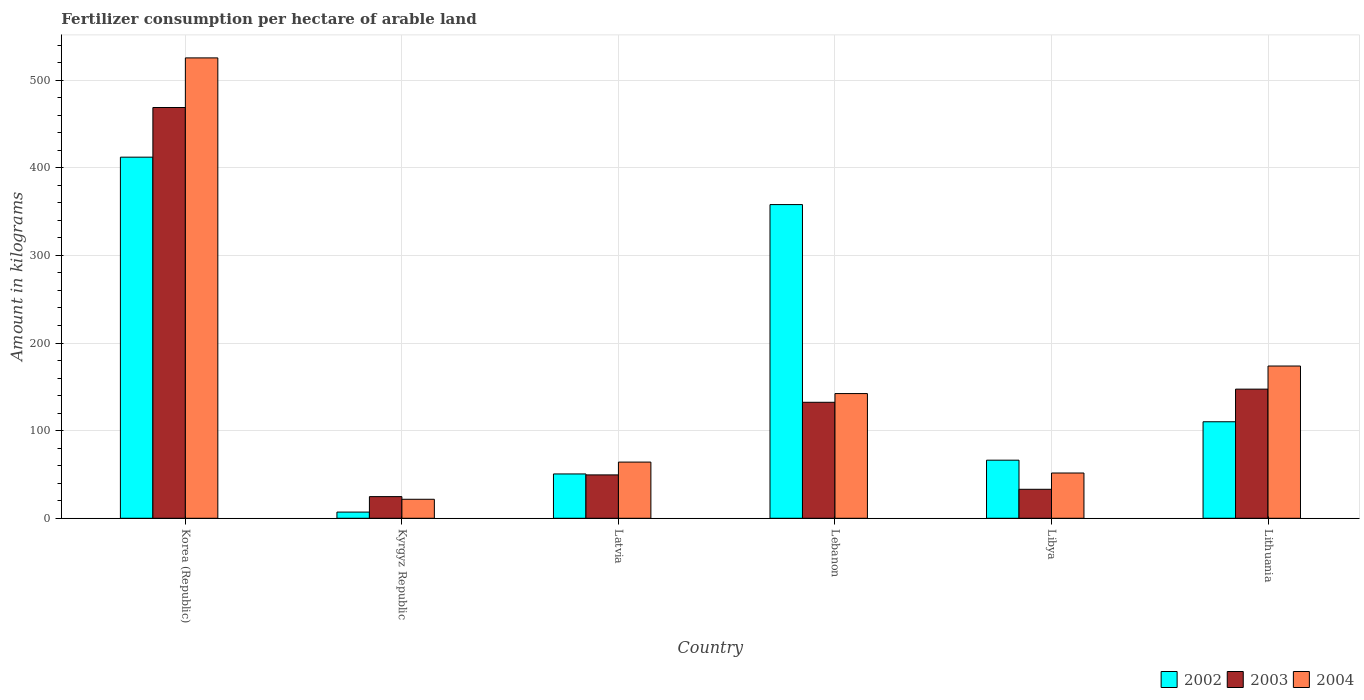How many different coloured bars are there?
Provide a short and direct response. 3. How many groups of bars are there?
Keep it short and to the point. 6. Are the number of bars per tick equal to the number of legend labels?
Provide a short and direct response. Yes. Are the number of bars on each tick of the X-axis equal?
Make the answer very short. Yes. How many bars are there on the 1st tick from the left?
Make the answer very short. 3. How many bars are there on the 3rd tick from the right?
Keep it short and to the point. 3. What is the label of the 3rd group of bars from the left?
Provide a succinct answer. Latvia. What is the amount of fertilizer consumption in 2004 in Libya?
Provide a succinct answer. 51.66. Across all countries, what is the maximum amount of fertilizer consumption in 2004?
Provide a succinct answer. 525.42. Across all countries, what is the minimum amount of fertilizer consumption in 2004?
Offer a terse response. 21.68. In which country was the amount of fertilizer consumption in 2004 maximum?
Ensure brevity in your answer.  Korea (Republic). In which country was the amount of fertilizer consumption in 2004 minimum?
Make the answer very short. Kyrgyz Republic. What is the total amount of fertilizer consumption in 2003 in the graph?
Your answer should be compact. 855.82. What is the difference between the amount of fertilizer consumption in 2004 in Korea (Republic) and that in Libya?
Provide a succinct answer. 473.77. What is the difference between the amount of fertilizer consumption in 2003 in Libya and the amount of fertilizer consumption in 2004 in Latvia?
Your answer should be compact. -31.06. What is the average amount of fertilizer consumption in 2004 per country?
Offer a very short reply. 163.16. What is the difference between the amount of fertilizer consumption of/in 2002 and amount of fertilizer consumption of/in 2003 in Lebanon?
Provide a succinct answer. 225.62. What is the ratio of the amount of fertilizer consumption in 2004 in Kyrgyz Republic to that in Latvia?
Provide a short and direct response. 0.34. Is the amount of fertilizer consumption in 2002 in Latvia less than that in Libya?
Your answer should be compact. Yes. What is the difference between the highest and the second highest amount of fertilizer consumption in 2002?
Offer a very short reply. -301.97. What is the difference between the highest and the lowest amount of fertilizer consumption in 2003?
Keep it short and to the point. 444.08. Is the sum of the amount of fertilizer consumption in 2003 in Lebanon and Libya greater than the maximum amount of fertilizer consumption in 2004 across all countries?
Your answer should be very brief. No. Is it the case that in every country, the sum of the amount of fertilizer consumption in 2003 and amount of fertilizer consumption in 2002 is greater than the amount of fertilizer consumption in 2004?
Make the answer very short. Yes. How many bars are there?
Offer a terse response. 18. How many countries are there in the graph?
Your response must be concise. 6. What is the difference between two consecutive major ticks on the Y-axis?
Provide a short and direct response. 100. How many legend labels are there?
Ensure brevity in your answer.  3. What is the title of the graph?
Offer a terse response. Fertilizer consumption per hectare of arable land. What is the label or title of the X-axis?
Offer a terse response. Country. What is the label or title of the Y-axis?
Your response must be concise. Amount in kilograms. What is the Amount in kilograms of 2002 in Korea (Republic)?
Provide a succinct answer. 412.13. What is the Amount in kilograms of 2003 in Korea (Republic)?
Offer a terse response. 468.79. What is the Amount in kilograms in 2004 in Korea (Republic)?
Provide a succinct answer. 525.42. What is the Amount in kilograms of 2002 in Kyrgyz Republic?
Make the answer very short. 7.05. What is the Amount in kilograms of 2003 in Kyrgyz Republic?
Keep it short and to the point. 24.71. What is the Amount in kilograms of 2004 in Kyrgyz Republic?
Provide a succinct answer. 21.68. What is the Amount in kilograms of 2002 in Latvia?
Keep it short and to the point. 50.6. What is the Amount in kilograms of 2003 in Latvia?
Offer a terse response. 49.49. What is the Amount in kilograms in 2004 in Latvia?
Your answer should be compact. 64.13. What is the Amount in kilograms of 2002 in Lebanon?
Provide a short and direct response. 358. What is the Amount in kilograms of 2003 in Lebanon?
Your answer should be very brief. 132.38. What is the Amount in kilograms in 2004 in Lebanon?
Offer a terse response. 142.32. What is the Amount in kilograms of 2002 in Libya?
Your answer should be very brief. 66.29. What is the Amount in kilograms in 2003 in Libya?
Your answer should be very brief. 33.07. What is the Amount in kilograms in 2004 in Libya?
Provide a succinct answer. 51.66. What is the Amount in kilograms of 2002 in Lithuania?
Your answer should be compact. 110.15. What is the Amount in kilograms in 2003 in Lithuania?
Make the answer very short. 147.38. What is the Amount in kilograms of 2004 in Lithuania?
Keep it short and to the point. 173.76. Across all countries, what is the maximum Amount in kilograms in 2002?
Offer a terse response. 412.13. Across all countries, what is the maximum Amount in kilograms in 2003?
Offer a terse response. 468.79. Across all countries, what is the maximum Amount in kilograms in 2004?
Your answer should be very brief. 525.42. Across all countries, what is the minimum Amount in kilograms of 2002?
Offer a very short reply. 7.05. Across all countries, what is the minimum Amount in kilograms of 2003?
Give a very brief answer. 24.71. Across all countries, what is the minimum Amount in kilograms of 2004?
Offer a very short reply. 21.68. What is the total Amount in kilograms of 2002 in the graph?
Offer a very short reply. 1004.22. What is the total Amount in kilograms of 2003 in the graph?
Make the answer very short. 855.82. What is the total Amount in kilograms of 2004 in the graph?
Make the answer very short. 978.97. What is the difference between the Amount in kilograms of 2002 in Korea (Republic) and that in Kyrgyz Republic?
Provide a short and direct response. 405.08. What is the difference between the Amount in kilograms in 2003 in Korea (Republic) and that in Kyrgyz Republic?
Keep it short and to the point. 444.08. What is the difference between the Amount in kilograms of 2004 in Korea (Republic) and that in Kyrgyz Republic?
Ensure brevity in your answer.  503.74. What is the difference between the Amount in kilograms of 2002 in Korea (Republic) and that in Latvia?
Provide a short and direct response. 361.53. What is the difference between the Amount in kilograms in 2003 in Korea (Republic) and that in Latvia?
Your response must be concise. 419.3. What is the difference between the Amount in kilograms of 2004 in Korea (Republic) and that in Latvia?
Make the answer very short. 461.29. What is the difference between the Amount in kilograms of 2002 in Korea (Republic) and that in Lebanon?
Offer a terse response. 54.13. What is the difference between the Amount in kilograms of 2003 in Korea (Republic) and that in Lebanon?
Make the answer very short. 336.42. What is the difference between the Amount in kilograms of 2004 in Korea (Republic) and that in Lebanon?
Provide a succinct answer. 383.1. What is the difference between the Amount in kilograms of 2002 in Korea (Republic) and that in Libya?
Your response must be concise. 345.84. What is the difference between the Amount in kilograms of 2003 in Korea (Republic) and that in Libya?
Ensure brevity in your answer.  435.72. What is the difference between the Amount in kilograms in 2004 in Korea (Republic) and that in Libya?
Give a very brief answer. 473.77. What is the difference between the Amount in kilograms in 2002 in Korea (Republic) and that in Lithuania?
Make the answer very short. 301.97. What is the difference between the Amount in kilograms in 2003 in Korea (Republic) and that in Lithuania?
Ensure brevity in your answer.  321.41. What is the difference between the Amount in kilograms of 2004 in Korea (Republic) and that in Lithuania?
Give a very brief answer. 351.66. What is the difference between the Amount in kilograms in 2002 in Kyrgyz Republic and that in Latvia?
Your answer should be very brief. -43.54. What is the difference between the Amount in kilograms in 2003 in Kyrgyz Republic and that in Latvia?
Ensure brevity in your answer.  -24.78. What is the difference between the Amount in kilograms of 2004 in Kyrgyz Republic and that in Latvia?
Keep it short and to the point. -42.45. What is the difference between the Amount in kilograms in 2002 in Kyrgyz Republic and that in Lebanon?
Offer a terse response. -350.95. What is the difference between the Amount in kilograms of 2003 in Kyrgyz Republic and that in Lebanon?
Your response must be concise. -107.66. What is the difference between the Amount in kilograms of 2004 in Kyrgyz Republic and that in Lebanon?
Give a very brief answer. -120.64. What is the difference between the Amount in kilograms in 2002 in Kyrgyz Republic and that in Libya?
Offer a very short reply. -59.24. What is the difference between the Amount in kilograms in 2003 in Kyrgyz Republic and that in Libya?
Your response must be concise. -8.36. What is the difference between the Amount in kilograms in 2004 in Kyrgyz Republic and that in Libya?
Your answer should be very brief. -29.97. What is the difference between the Amount in kilograms of 2002 in Kyrgyz Republic and that in Lithuania?
Offer a very short reply. -103.1. What is the difference between the Amount in kilograms in 2003 in Kyrgyz Republic and that in Lithuania?
Ensure brevity in your answer.  -122.67. What is the difference between the Amount in kilograms of 2004 in Kyrgyz Republic and that in Lithuania?
Your answer should be very brief. -152.08. What is the difference between the Amount in kilograms of 2002 in Latvia and that in Lebanon?
Give a very brief answer. -307.4. What is the difference between the Amount in kilograms of 2003 in Latvia and that in Lebanon?
Your answer should be compact. -82.88. What is the difference between the Amount in kilograms of 2004 in Latvia and that in Lebanon?
Ensure brevity in your answer.  -78.19. What is the difference between the Amount in kilograms in 2002 in Latvia and that in Libya?
Keep it short and to the point. -15.7. What is the difference between the Amount in kilograms in 2003 in Latvia and that in Libya?
Make the answer very short. 16.42. What is the difference between the Amount in kilograms of 2004 in Latvia and that in Libya?
Your answer should be very brief. 12.47. What is the difference between the Amount in kilograms in 2002 in Latvia and that in Lithuania?
Your answer should be compact. -59.56. What is the difference between the Amount in kilograms in 2003 in Latvia and that in Lithuania?
Give a very brief answer. -97.89. What is the difference between the Amount in kilograms in 2004 in Latvia and that in Lithuania?
Offer a terse response. -109.63. What is the difference between the Amount in kilograms of 2002 in Lebanon and that in Libya?
Make the answer very short. 291.71. What is the difference between the Amount in kilograms of 2003 in Lebanon and that in Libya?
Offer a terse response. 99.31. What is the difference between the Amount in kilograms of 2004 in Lebanon and that in Libya?
Ensure brevity in your answer.  90.66. What is the difference between the Amount in kilograms in 2002 in Lebanon and that in Lithuania?
Give a very brief answer. 247.84. What is the difference between the Amount in kilograms of 2003 in Lebanon and that in Lithuania?
Your response must be concise. -15.01. What is the difference between the Amount in kilograms of 2004 in Lebanon and that in Lithuania?
Offer a terse response. -31.44. What is the difference between the Amount in kilograms in 2002 in Libya and that in Lithuania?
Your response must be concise. -43.86. What is the difference between the Amount in kilograms of 2003 in Libya and that in Lithuania?
Give a very brief answer. -114.31. What is the difference between the Amount in kilograms in 2004 in Libya and that in Lithuania?
Ensure brevity in your answer.  -122.1. What is the difference between the Amount in kilograms of 2002 in Korea (Republic) and the Amount in kilograms of 2003 in Kyrgyz Republic?
Keep it short and to the point. 387.42. What is the difference between the Amount in kilograms of 2002 in Korea (Republic) and the Amount in kilograms of 2004 in Kyrgyz Republic?
Offer a terse response. 390.45. What is the difference between the Amount in kilograms in 2003 in Korea (Republic) and the Amount in kilograms in 2004 in Kyrgyz Republic?
Your response must be concise. 447.11. What is the difference between the Amount in kilograms in 2002 in Korea (Republic) and the Amount in kilograms in 2003 in Latvia?
Provide a short and direct response. 362.63. What is the difference between the Amount in kilograms in 2002 in Korea (Republic) and the Amount in kilograms in 2004 in Latvia?
Your answer should be very brief. 348. What is the difference between the Amount in kilograms in 2003 in Korea (Republic) and the Amount in kilograms in 2004 in Latvia?
Give a very brief answer. 404.66. What is the difference between the Amount in kilograms of 2002 in Korea (Republic) and the Amount in kilograms of 2003 in Lebanon?
Offer a very short reply. 279.75. What is the difference between the Amount in kilograms in 2002 in Korea (Republic) and the Amount in kilograms in 2004 in Lebanon?
Your response must be concise. 269.81. What is the difference between the Amount in kilograms of 2003 in Korea (Republic) and the Amount in kilograms of 2004 in Lebanon?
Give a very brief answer. 326.47. What is the difference between the Amount in kilograms of 2002 in Korea (Republic) and the Amount in kilograms of 2003 in Libya?
Offer a very short reply. 379.06. What is the difference between the Amount in kilograms of 2002 in Korea (Republic) and the Amount in kilograms of 2004 in Libya?
Make the answer very short. 360.47. What is the difference between the Amount in kilograms of 2003 in Korea (Republic) and the Amount in kilograms of 2004 in Libya?
Keep it short and to the point. 417.13. What is the difference between the Amount in kilograms of 2002 in Korea (Republic) and the Amount in kilograms of 2003 in Lithuania?
Keep it short and to the point. 264.74. What is the difference between the Amount in kilograms in 2002 in Korea (Republic) and the Amount in kilograms in 2004 in Lithuania?
Provide a short and direct response. 238.37. What is the difference between the Amount in kilograms in 2003 in Korea (Republic) and the Amount in kilograms in 2004 in Lithuania?
Your answer should be compact. 295.03. What is the difference between the Amount in kilograms in 2002 in Kyrgyz Republic and the Amount in kilograms in 2003 in Latvia?
Ensure brevity in your answer.  -42.44. What is the difference between the Amount in kilograms in 2002 in Kyrgyz Republic and the Amount in kilograms in 2004 in Latvia?
Offer a terse response. -57.08. What is the difference between the Amount in kilograms of 2003 in Kyrgyz Republic and the Amount in kilograms of 2004 in Latvia?
Make the answer very short. -39.42. What is the difference between the Amount in kilograms in 2002 in Kyrgyz Republic and the Amount in kilograms in 2003 in Lebanon?
Provide a short and direct response. -125.32. What is the difference between the Amount in kilograms in 2002 in Kyrgyz Republic and the Amount in kilograms in 2004 in Lebanon?
Provide a succinct answer. -135.27. What is the difference between the Amount in kilograms in 2003 in Kyrgyz Republic and the Amount in kilograms in 2004 in Lebanon?
Your response must be concise. -117.61. What is the difference between the Amount in kilograms in 2002 in Kyrgyz Republic and the Amount in kilograms in 2003 in Libya?
Your response must be concise. -26.02. What is the difference between the Amount in kilograms in 2002 in Kyrgyz Republic and the Amount in kilograms in 2004 in Libya?
Provide a short and direct response. -44.61. What is the difference between the Amount in kilograms of 2003 in Kyrgyz Republic and the Amount in kilograms of 2004 in Libya?
Give a very brief answer. -26.95. What is the difference between the Amount in kilograms in 2002 in Kyrgyz Republic and the Amount in kilograms in 2003 in Lithuania?
Give a very brief answer. -140.33. What is the difference between the Amount in kilograms of 2002 in Kyrgyz Republic and the Amount in kilograms of 2004 in Lithuania?
Make the answer very short. -166.71. What is the difference between the Amount in kilograms of 2003 in Kyrgyz Republic and the Amount in kilograms of 2004 in Lithuania?
Your answer should be compact. -149.05. What is the difference between the Amount in kilograms in 2002 in Latvia and the Amount in kilograms in 2003 in Lebanon?
Make the answer very short. -81.78. What is the difference between the Amount in kilograms of 2002 in Latvia and the Amount in kilograms of 2004 in Lebanon?
Give a very brief answer. -91.72. What is the difference between the Amount in kilograms in 2003 in Latvia and the Amount in kilograms in 2004 in Lebanon?
Keep it short and to the point. -92.82. What is the difference between the Amount in kilograms of 2002 in Latvia and the Amount in kilograms of 2003 in Libya?
Offer a terse response. 17.53. What is the difference between the Amount in kilograms in 2002 in Latvia and the Amount in kilograms in 2004 in Libya?
Give a very brief answer. -1.06. What is the difference between the Amount in kilograms of 2003 in Latvia and the Amount in kilograms of 2004 in Libya?
Offer a terse response. -2.16. What is the difference between the Amount in kilograms in 2002 in Latvia and the Amount in kilograms in 2003 in Lithuania?
Keep it short and to the point. -96.79. What is the difference between the Amount in kilograms in 2002 in Latvia and the Amount in kilograms in 2004 in Lithuania?
Offer a terse response. -123.17. What is the difference between the Amount in kilograms in 2003 in Latvia and the Amount in kilograms in 2004 in Lithuania?
Your answer should be very brief. -124.27. What is the difference between the Amount in kilograms of 2002 in Lebanon and the Amount in kilograms of 2003 in Libya?
Provide a short and direct response. 324.93. What is the difference between the Amount in kilograms in 2002 in Lebanon and the Amount in kilograms in 2004 in Libya?
Give a very brief answer. 306.34. What is the difference between the Amount in kilograms of 2003 in Lebanon and the Amount in kilograms of 2004 in Libya?
Make the answer very short. 80.72. What is the difference between the Amount in kilograms of 2002 in Lebanon and the Amount in kilograms of 2003 in Lithuania?
Ensure brevity in your answer.  210.62. What is the difference between the Amount in kilograms in 2002 in Lebanon and the Amount in kilograms in 2004 in Lithuania?
Keep it short and to the point. 184.24. What is the difference between the Amount in kilograms of 2003 in Lebanon and the Amount in kilograms of 2004 in Lithuania?
Your answer should be very brief. -41.39. What is the difference between the Amount in kilograms of 2002 in Libya and the Amount in kilograms of 2003 in Lithuania?
Give a very brief answer. -81.09. What is the difference between the Amount in kilograms in 2002 in Libya and the Amount in kilograms in 2004 in Lithuania?
Make the answer very short. -107.47. What is the difference between the Amount in kilograms in 2003 in Libya and the Amount in kilograms in 2004 in Lithuania?
Provide a short and direct response. -140.69. What is the average Amount in kilograms in 2002 per country?
Give a very brief answer. 167.37. What is the average Amount in kilograms of 2003 per country?
Offer a terse response. 142.64. What is the average Amount in kilograms of 2004 per country?
Your answer should be compact. 163.16. What is the difference between the Amount in kilograms of 2002 and Amount in kilograms of 2003 in Korea (Republic)?
Your answer should be compact. -56.66. What is the difference between the Amount in kilograms of 2002 and Amount in kilograms of 2004 in Korea (Republic)?
Make the answer very short. -113.3. What is the difference between the Amount in kilograms in 2003 and Amount in kilograms in 2004 in Korea (Republic)?
Your answer should be compact. -56.63. What is the difference between the Amount in kilograms in 2002 and Amount in kilograms in 2003 in Kyrgyz Republic?
Your answer should be very brief. -17.66. What is the difference between the Amount in kilograms in 2002 and Amount in kilograms in 2004 in Kyrgyz Republic?
Provide a short and direct response. -14.63. What is the difference between the Amount in kilograms of 2003 and Amount in kilograms of 2004 in Kyrgyz Republic?
Make the answer very short. 3.03. What is the difference between the Amount in kilograms of 2002 and Amount in kilograms of 2003 in Latvia?
Provide a succinct answer. 1.1. What is the difference between the Amount in kilograms of 2002 and Amount in kilograms of 2004 in Latvia?
Ensure brevity in your answer.  -13.53. What is the difference between the Amount in kilograms in 2003 and Amount in kilograms in 2004 in Latvia?
Provide a short and direct response. -14.63. What is the difference between the Amount in kilograms in 2002 and Amount in kilograms in 2003 in Lebanon?
Your answer should be very brief. 225.62. What is the difference between the Amount in kilograms of 2002 and Amount in kilograms of 2004 in Lebanon?
Provide a succinct answer. 215.68. What is the difference between the Amount in kilograms of 2003 and Amount in kilograms of 2004 in Lebanon?
Make the answer very short. -9.94. What is the difference between the Amount in kilograms in 2002 and Amount in kilograms in 2003 in Libya?
Offer a terse response. 33.22. What is the difference between the Amount in kilograms in 2002 and Amount in kilograms in 2004 in Libya?
Give a very brief answer. 14.64. What is the difference between the Amount in kilograms of 2003 and Amount in kilograms of 2004 in Libya?
Your answer should be compact. -18.59. What is the difference between the Amount in kilograms of 2002 and Amount in kilograms of 2003 in Lithuania?
Your response must be concise. -37.23. What is the difference between the Amount in kilograms of 2002 and Amount in kilograms of 2004 in Lithuania?
Ensure brevity in your answer.  -63.61. What is the difference between the Amount in kilograms of 2003 and Amount in kilograms of 2004 in Lithuania?
Your answer should be compact. -26.38. What is the ratio of the Amount in kilograms in 2002 in Korea (Republic) to that in Kyrgyz Republic?
Your answer should be very brief. 58.45. What is the ratio of the Amount in kilograms in 2003 in Korea (Republic) to that in Kyrgyz Republic?
Your answer should be compact. 18.97. What is the ratio of the Amount in kilograms of 2004 in Korea (Republic) to that in Kyrgyz Republic?
Give a very brief answer. 24.23. What is the ratio of the Amount in kilograms in 2002 in Korea (Republic) to that in Latvia?
Offer a very short reply. 8.15. What is the ratio of the Amount in kilograms of 2003 in Korea (Republic) to that in Latvia?
Your response must be concise. 9.47. What is the ratio of the Amount in kilograms of 2004 in Korea (Republic) to that in Latvia?
Offer a terse response. 8.19. What is the ratio of the Amount in kilograms in 2002 in Korea (Republic) to that in Lebanon?
Provide a short and direct response. 1.15. What is the ratio of the Amount in kilograms of 2003 in Korea (Republic) to that in Lebanon?
Offer a very short reply. 3.54. What is the ratio of the Amount in kilograms in 2004 in Korea (Republic) to that in Lebanon?
Provide a succinct answer. 3.69. What is the ratio of the Amount in kilograms in 2002 in Korea (Republic) to that in Libya?
Provide a short and direct response. 6.22. What is the ratio of the Amount in kilograms of 2003 in Korea (Republic) to that in Libya?
Your answer should be compact. 14.18. What is the ratio of the Amount in kilograms in 2004 in Korea (Republic) to that in Libya?
Give a very brief answer. 10.17. What is the ratio of the Amount in kilograms in 2002 in Korea (Republic) to that in Lithuania?
Your answer should be very brief. 3.74. What is the ratio of the Amount in kilograms in 2003 in Korea (Republic) to that in Lithuania?
Your answer should be very brief. 3.18. What is the ratio of the Amount in kilograms in 2004 in Korea (Republic) to that in Lithuania?
Your answer should be compact. 3.02. What is the ratio of the Amount in kilograms of 2002 in Kyrgyz Republic to that in Latvia?
Offer a terse response. 0.14. What is the ratio of the Amount in kilograms in 2003 in Kyrgyz Republic to that in Latvia?
Offer a terse response. 0.5. What is the ratio of the Amount in kilograms in 2004 in Kyrgyz Republic to that in Latvia?
Your answer should be very brief. 0.34. What is the ratio of the Amount in kilograms in 2002 in Kyrgyz Republic to that in Lebanon?
Offer a terse response. 0.02. What is the ratio of the Amount in kilograms in 2003 in Kyrgyz Republic to that in Lebanon?
Your answer should be compact. 0.19. What is the ratio of the Amount in kilograms of 2004 in Kyrgyz Republic to that in Lebanon?
Your response must be concise. 0.15. What is the ratio of the Amount in kilograms of 2002 in Kyrgyz Republic to that in Libya?
Keep it short and to the point. 0.11. What is the ratio of the Amount in kilograms of 2003 in Kyrgyz Republic to that in Libya?
Your response must be concise. 0.75. What is the ratio of the Amount in kilograms of 2004 in Kyrgyz Republic to that in Libya?
Provide a short and direct response. 0.42. What is the ratio of the Amount in kilograms in 2002 in Kyrgyz Republic to that in Lithuania?
Provide a succinct answer. 0.06. What is the ratio of the Amount in kilograms in 2003 in Kyrgyz Republic to that in Lithuania?
Provide a succinct answer. 0.17. What is the ratio of the Amount in kilograms of 2004 in Kyrgyz Republic to that in Lithuania?
Give a very brief answer. 0.12. What is the ratio of the Amount in kilograms in 2002 in Latvia to that in Lebanon?
Make the answer very short. 0.14. What is the ratio of the Amount in kilograms in 2003 in Latvia to that in Lebanon?
Keep it short and to the point. 0.37. What is the ratio of the Amount in kilograms of 2004 in Latvia to that in Lebanon?
Provide a succinct answer. 0.45. What is the ratio of the Amount in kilograms in 2002 in Latvia to that in Libya?
Your response must be concise. 0.76. What is the ratio of the Amount in kilograms in 2003 in Latvia to that in Libya?
Make the answer very short. 1.5. What is the ratio of the Amount in kilograms of 2004 in Latvia to that in Libya?
Your response must be concise. 1.24. What is the ratio of the Amount in kilograms of 2002 in Latvia to that in Lithuania?
Keep it short and to the point. 0.46. What is the ratio of the Amount in kilograms of 2003 in Latvia to that in Lithuania?
Provide a succinct answer. 0.34. What is the ratio of the Amount in kilograms in 2004 in Latvia to that in Lithuania?
Keep it short and to the point. 0.37. What is the ratio of the Amount in kilograms in 2002 in Lebanon to that in Libya?
Provide a succinct answer. 5.4. What is the ratio of the Amount in kilograms in 2003 in Lebanon to that in Libya?
Your answer should be compact. 4. What is the ratio of the Amount in kilograms in 2004 in Lebanon to that in Libya?
Keep it short and to the point. 2.76. What is the ratio of the Amount in kilograms in 2002 in Lebanon to that in Lithuania?
Provide a short and direct response. 3.25. What is the ratio of the Amount in kilograms in 2003 in Lebanon to that in Lithuania?
Ensure brevity in your answer.  0.9. What is the ratio of the Amount in kilograms in 2004 in Lebanon to that in Lithuania?
Offer a very short reply. 0.82. What is the ratio of the Amount in kilograms in 2002 in Libya to that in Lithuania?
Provide a short and direct response. 0.6. What is the ratio of the Amount in kilograms in 2003 in Libya to that in Lithuania?
Your answer should be very brief. 0.22. What is the ratio of the Amount in kilograms of 2004 in Libya to that in Lithuania?
Give a very brief answer. 0.3. What is the difference between the highest and the second highest Amount in kilograms in 2002?
Provide a short and direct response. 54.13. What is the difference between the highest and the second highest Amount in kilograms of 2003?
Your response must be concise. 321.41. What is the difference between the highest and the second highest Amount in kilograms of 2004?
Provide a succinct answer. 351.66. What is the difference between the highest and the lowest Amount in kilograms of 2002?
Offer a very short reply. 405.08. What is the difference between the highest and the lowest Amount in kilograms of 2003?
Your answer should be compact. 444.08. What is the difference between the highest and the lowest Amount in kilograms of 2004?
Your answer should be compact. 503.74. 